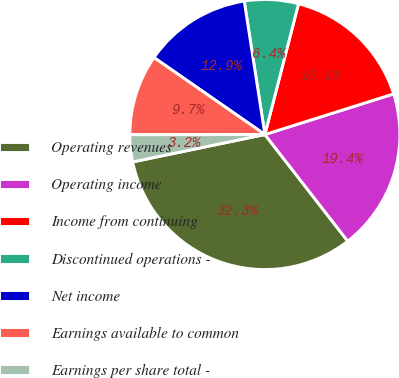Convert chart. <chart><loc_0><loc_0><loc_500><loc_500><pie_chart><fcel>Operating revenues<fcel>Operating income<fcel>Income from continuing<fcel>Discontinued operations -<fcel>Net income<fcel>Earnings available to common<fcel>Earnings per share total -<nl><fcel>32.26%<fcel>19.35%<fcel>16.13%<fcel>6.45%<fcel>12.9%<fcel>9.68%<fcel>3.23%<nl></chart> 